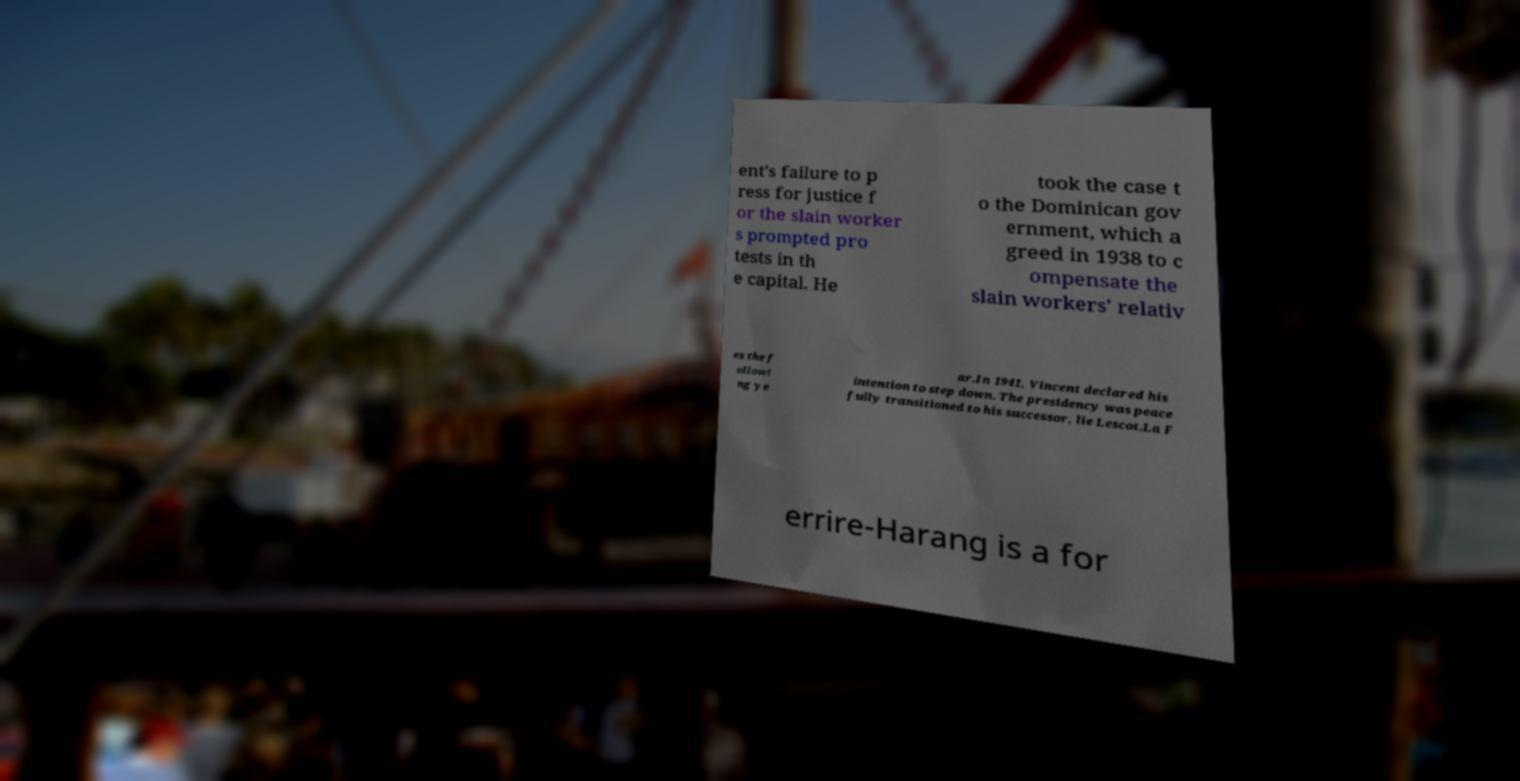I need the written content from this picture converted into text. Can you do that? ent's failure to p ress for justice f or the slain worker s prompted pro tests in th e capital. He took the case t o the Dominican gov ernment, which a greed in 1938 to c ompensate the slain workers’ relativ es the f ollowi ng ye ar.In 1941, Vincent declared his intention to step down. The presidency was peace fully transitioned to his successor, lie Lescot.La F errire-Harang is a for 